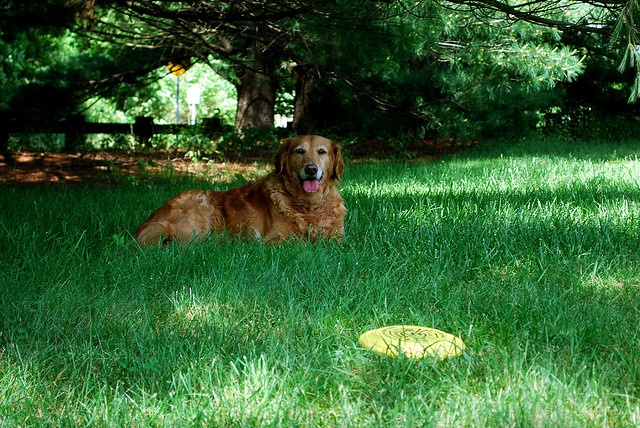Describe the objects in this image and their specific colors. I can see dog in black, olive, maroon, and gray tones and frisbee in black, khaki, and lightyellow tones in this image. 